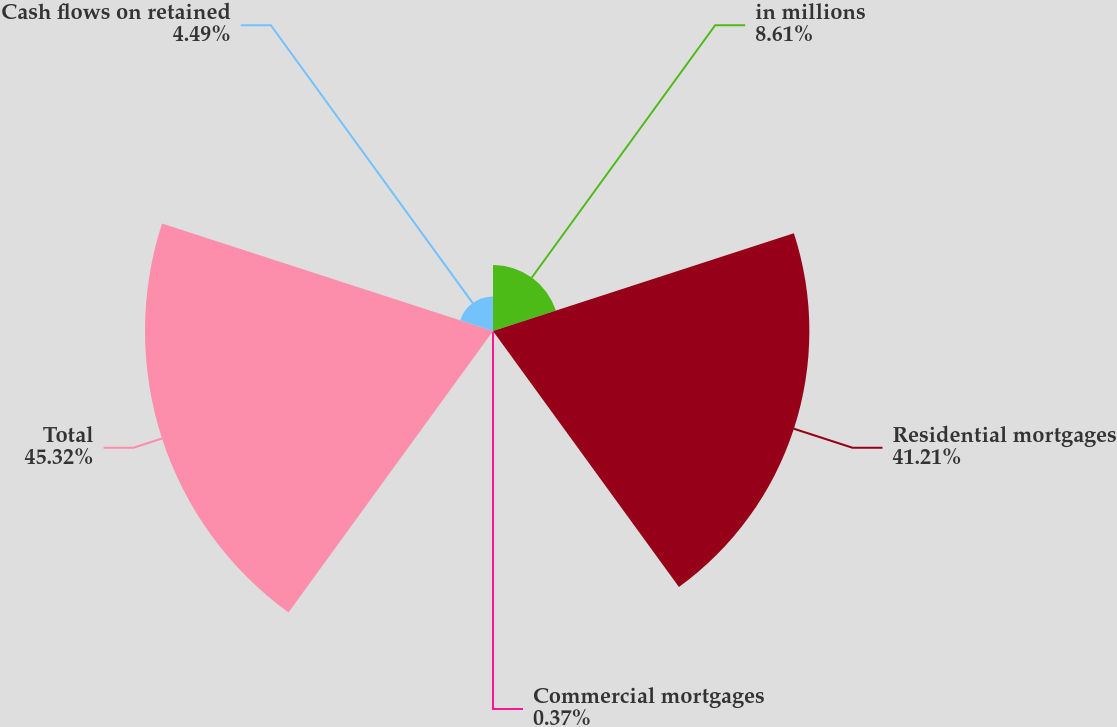<chart> <loc_0><loc_0><loc_500><loc_500><pie_chart><fcel>in millions<fcel>Residential mortgages<fcel>Commercial mortgages<fcel>Total<fcel>Cash flows on retained<nl><fcel>8.61%<fcel>41.21%<fcel>0.37%<fcel>45.33%<fcel>4.49%<nl></chart> 